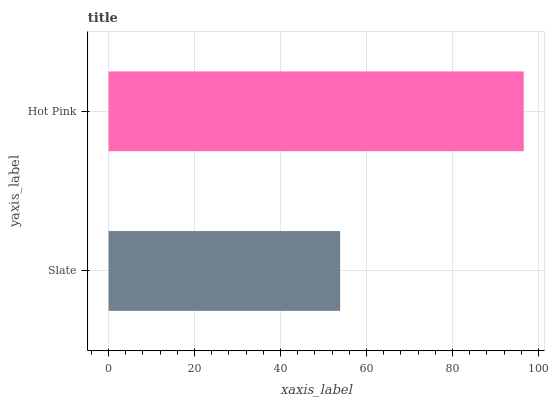Is Slate the minimum?
Answer yes or no. Yes. Is Hot Pink the maximum?
Answer yes or no. Yes. Is Hot Pink the minimum?
Answer yes or no. No. Is Hot Pink greater than Slate?
Answer yes or no. Yes. Is Slate less than Hot Pink?
Answer yes or no. Yes. Is Slate greater than Hot Pink?
Answer yes or no. No. Is Hot Pink less than Slate?
Answer yes or no. No. Is Hot Pink the high median?
Answer yes or no. Yes. Is Slate the low median?
Answer yes or no. Yes. Is Slate the high median?
Answer yes or no. No. Is Hot Pink the low median?
Answer yes or no. No. 